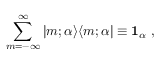<formula> <loc_0><loc_0><loc_500><loc_500>\sum _ { m = - \infty } ^ { \infty } | m ; \alpha \rangle \langle m ; \alpha | \equiv 1 _ { \alpha } \ ,</formula> 